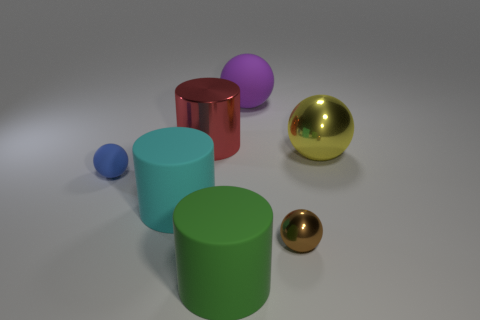What number of blue objects are big rubber balls or large balls?
Make the answer very short. 0. Is there a blue matte object of the same size as the cyan cylinder?
Give a very brief answer. No. How many tiny matte cylinders are there?
Your answer should be very brief. 0. How many large objects are either rubber cylinders or brown matte objects?
Offer a very short reply. 2. There is a tiny ball that is to the left of the rubber thing that is behind the rubber ball on the left side of the big purple matte ball; what is its color?
Provide a succinct answer. Blue. How many shiny objects are green objects or spheres?
Your answer should be very brief. 2. There is a sphere that is behind the yellow metal thing; is its color the same as the shiny object that is in front of the yellow metal ball?
Your answer should be compact. No. What size is the cyan matte thing that is the same shape as the large red metal object?
Provide a succinct answer. Large. Are there more big rubber objects that are in front of the large cyan matte cylinder than blue matte balls?
Offer a terse response. No. Are the ball left of the large green matte thing and the large cyan object made of the same material?
Provide a succinct answer. Yes. 